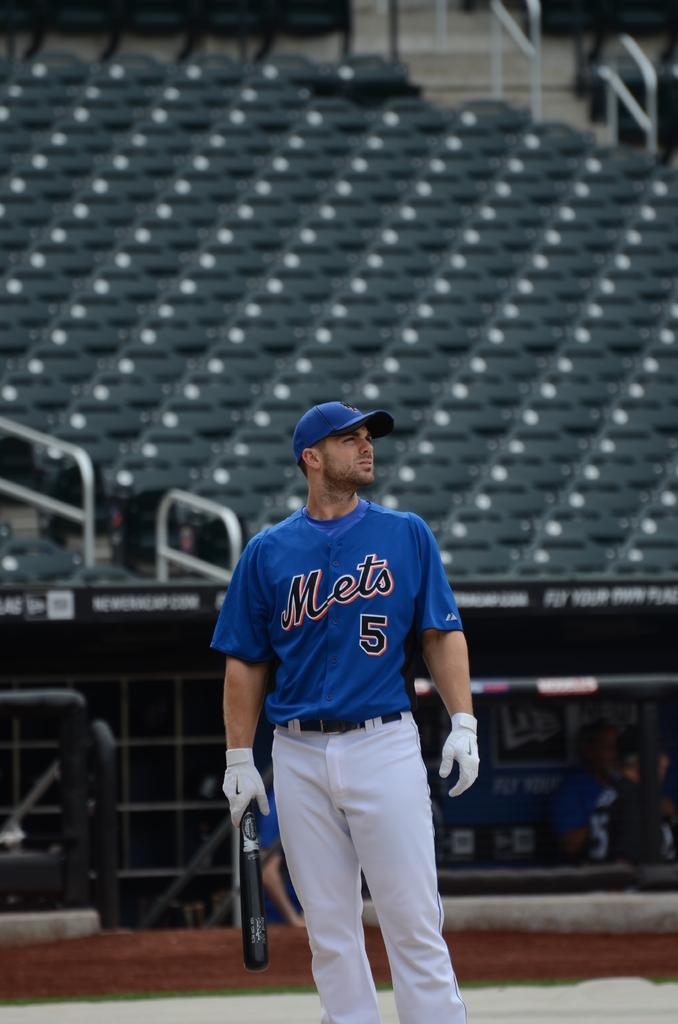<image>
Share a concise interpretation of the image provided. A baseball player with the number 5 on his jersey is standing on a baseball field. 